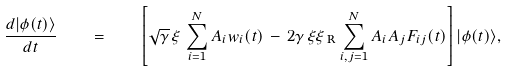Convert formula to latex. <formula><loc_0><loc_0><loc_500><loc_500>\frac { d | \phi ( t ) \rangle } { d t } \quad = \quad \left [ \sqrt { \gamma } \, \xi \, \sum _ { i = 1 } ^ { N } A _ { i } w _ { i } ( t ) \, - \, 2 \gamma \, \xi \xi _ { \text { R} } \sum _ { i , j = 1 } ^ { N } A _ { i } A _ { j } F _ { i j } ( t ) \right ] | \phi ( t ) \rangle ,</formula> 